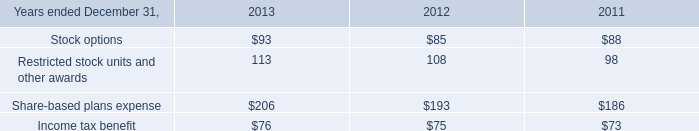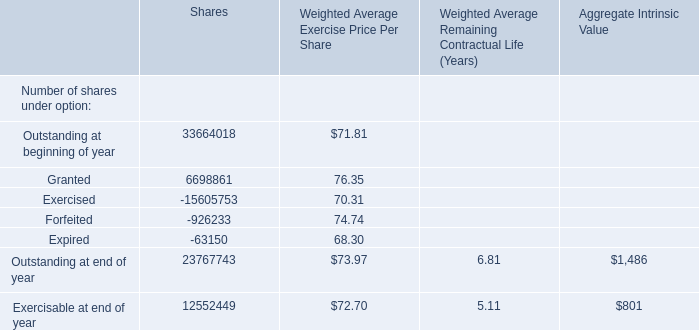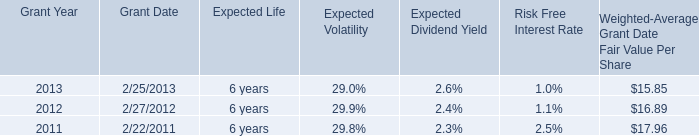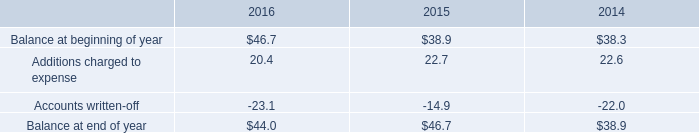Does the average value of Stock options in 2013 greater than that in 2012? 
Answer: yes. 